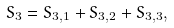<formula> <loc_0><loc_0><loc_500><loc_500>S _ { 3 } = S _ { 3 , 1 } + S _ { 3 , 2 } + S _ { 3 , 3 } ,</formula> 